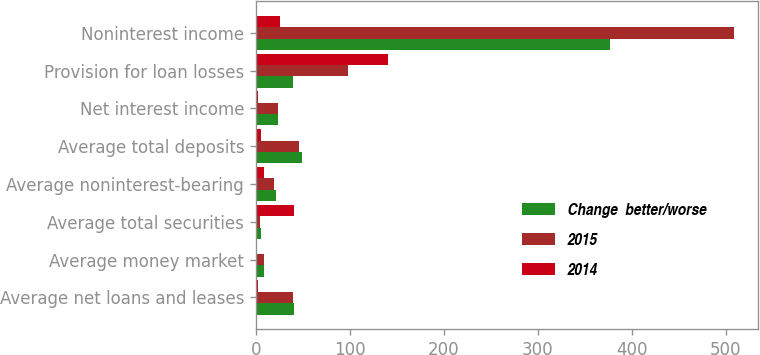Convert chart. <chart><loc_0><loc_0><loc_500><loc_500><stacked_bar_chart><ecel><fcel>Average net loans and leases<fcel>Average money market<fcel>Average total securities<fcel>Average noninterest-bearing<fcel>Average total deposits<fcel>Net interest income<fcel>Provision for loan losses<fcel>Noninterest income<nl><fcel>Change  better/worse<fcel>40.2<fcel>8.3<fcel>5.8<fcel>21.4<fcel>48.6<fcel>23.7<fcel>40<fcel>377.1<nl><fcel>2015<fcel>39.5<fcel>8.2<fcel>4.1<fcel>19.6<fcel>46.3<fcel>23.7<fcel>98.1<fcel>508.6<nl><fcel>2014<fcel>2<fcel>1<fcel>41<fcel>9<fcel>5<fcel>2<fcel>141<fcel>26<nl></chart> 